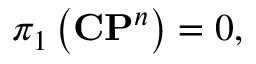Convert formula to latex. <formula><loc_0><loc_0><loc_500><loc_500>\pi _ { 1 } \left ( { C P } ^ { n } \right ) = 0 ,</formula> 